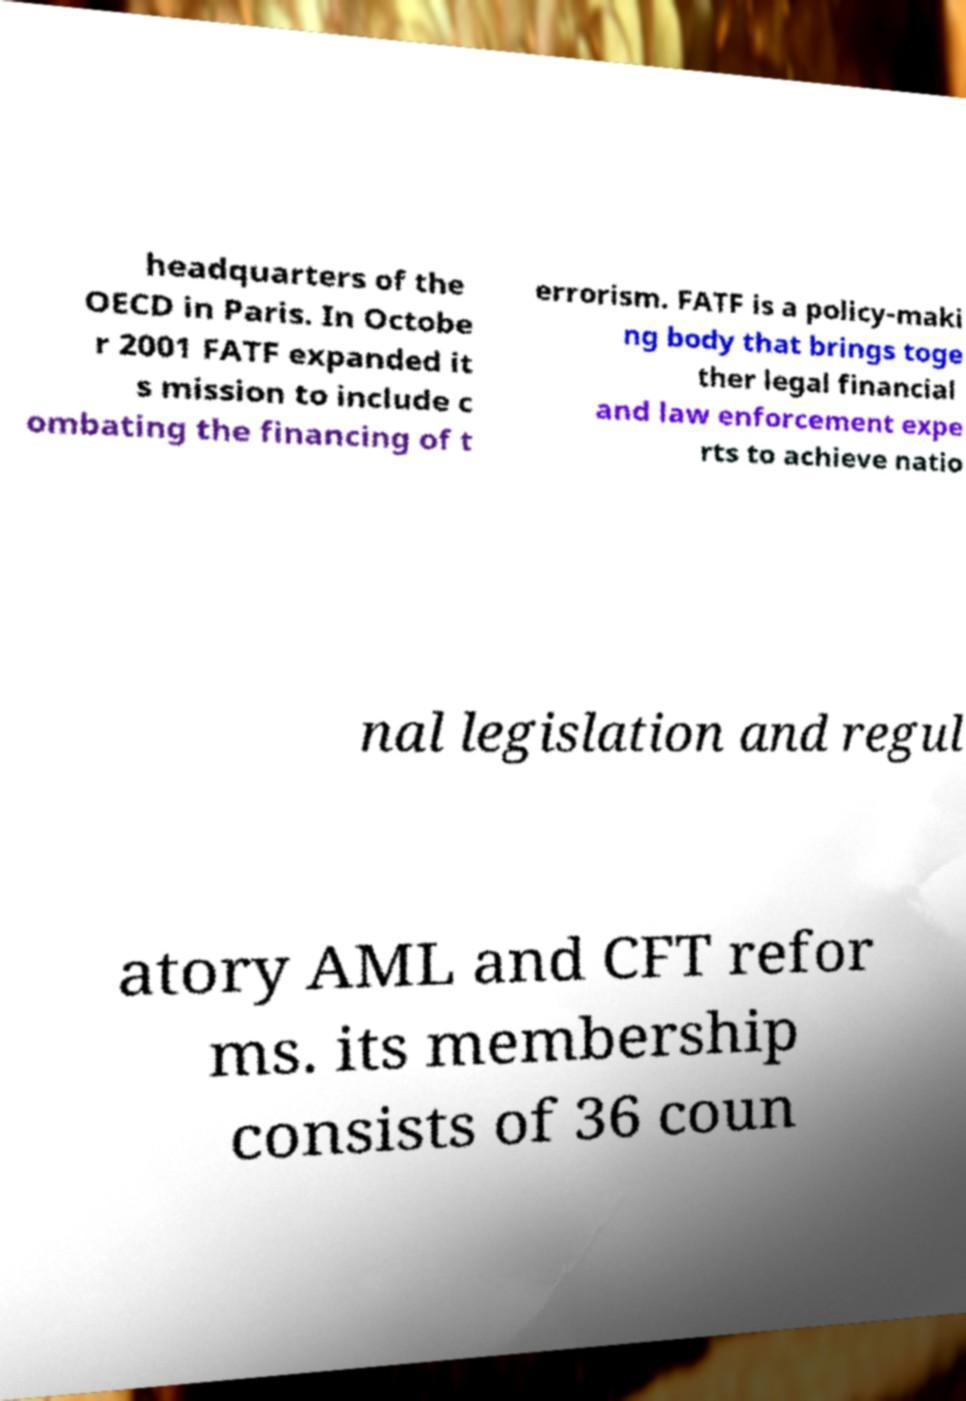Can you accurately transcribe the text from the provided image for me? headquarters of the OECD in Paris. In Octobe r 2001 FATF expanded it s mission to include c ombating the financing of t errorism. FATF is a policy-maki ng body that brings toge ther legal financial and law enforcement expe rts to achieve natio nal legislation and regul atory AML and CFT refor ms. its membership consists of 36 coun 